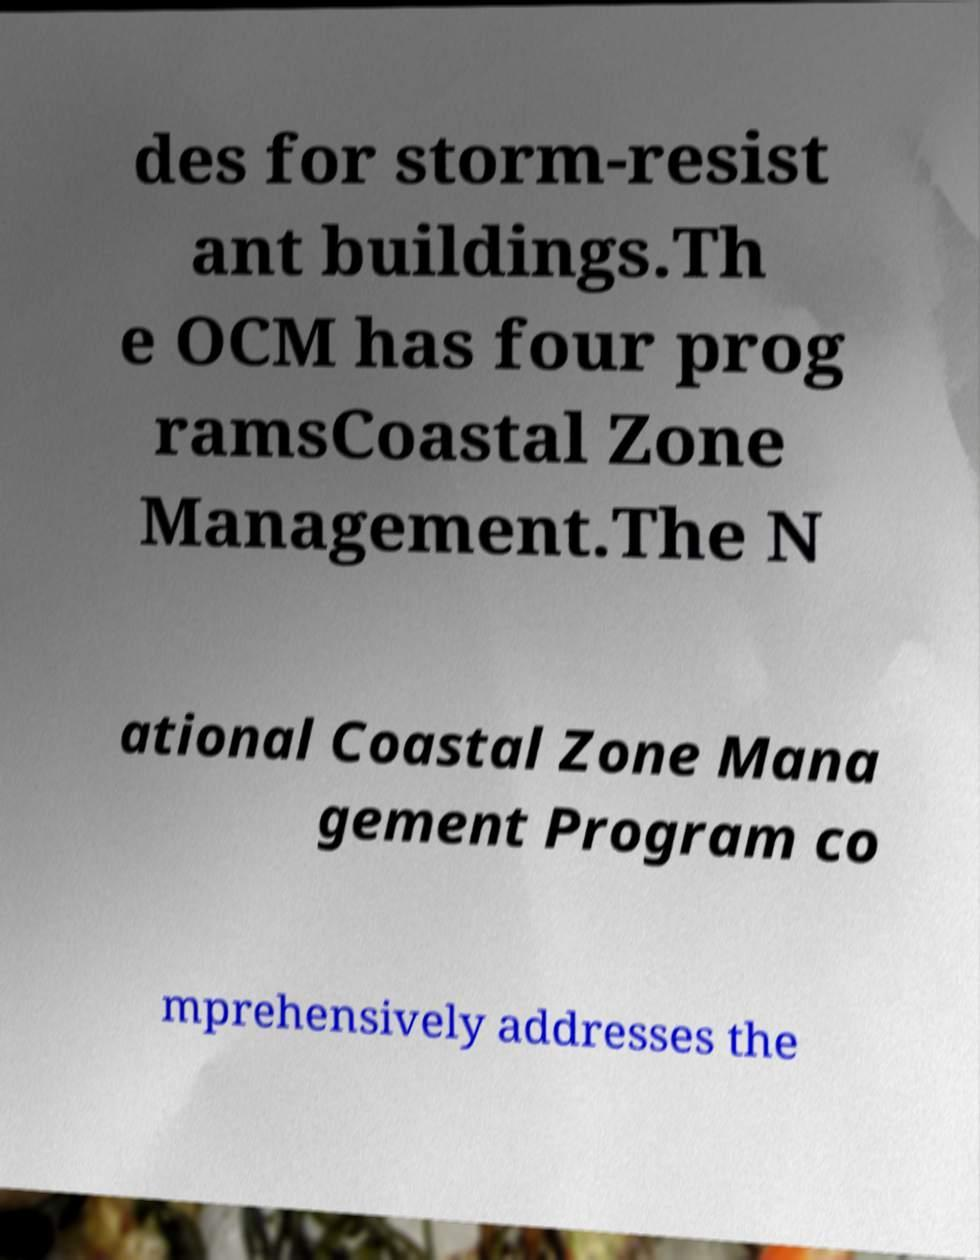There's text embedded in this image that I need extracted. Can you transcribe it verbatim? des for storm-resist ant buildings.Th e OCM has four prog ramsCoastal Zone Management.The N ational Coastal Zone Mana gement Program co mprehensively addresses the 